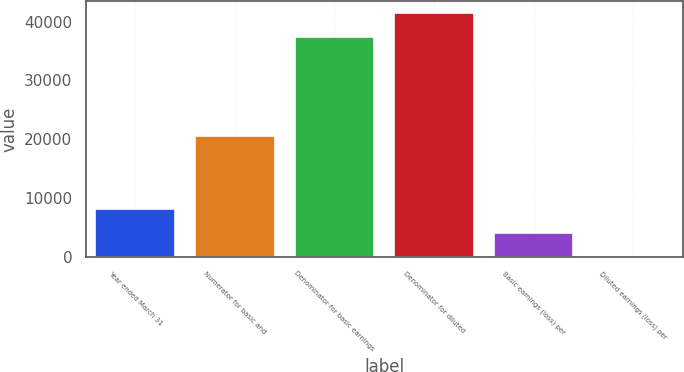Convert chart. <chart><loc_0><loc_0><loc_500><loc_500><bar_chart><fcel>Year ended March 31<fcel>Numerator for basic and<fcel>Denominator for basic earnings<fcel>Denominator for diluted<fcel>Basic earnings (loss) per<fcel>Diluted earnings (loss) per<nl><fcel>8220.4<fcel>20507<fcel>37298<fcel>41407.9<fcel>4110.45<fcel>0.5<nl></chart> 